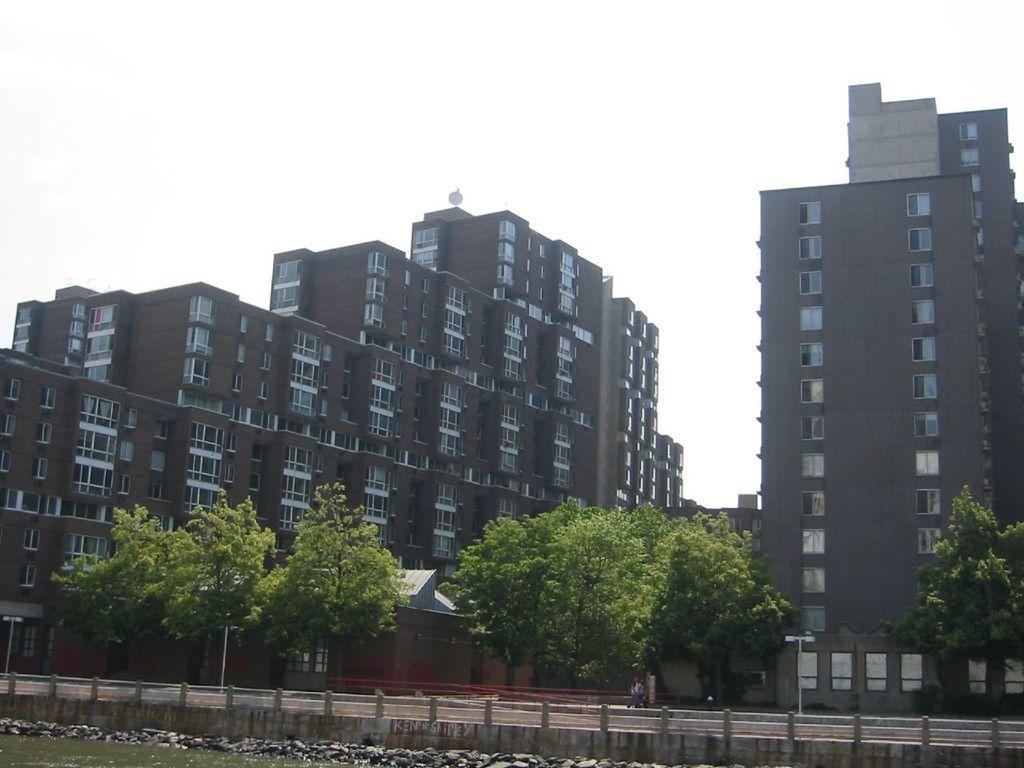Could you give a brief overview of what you see in this image? In this image I can see some buildings, in-front of them there are some trees and road. 